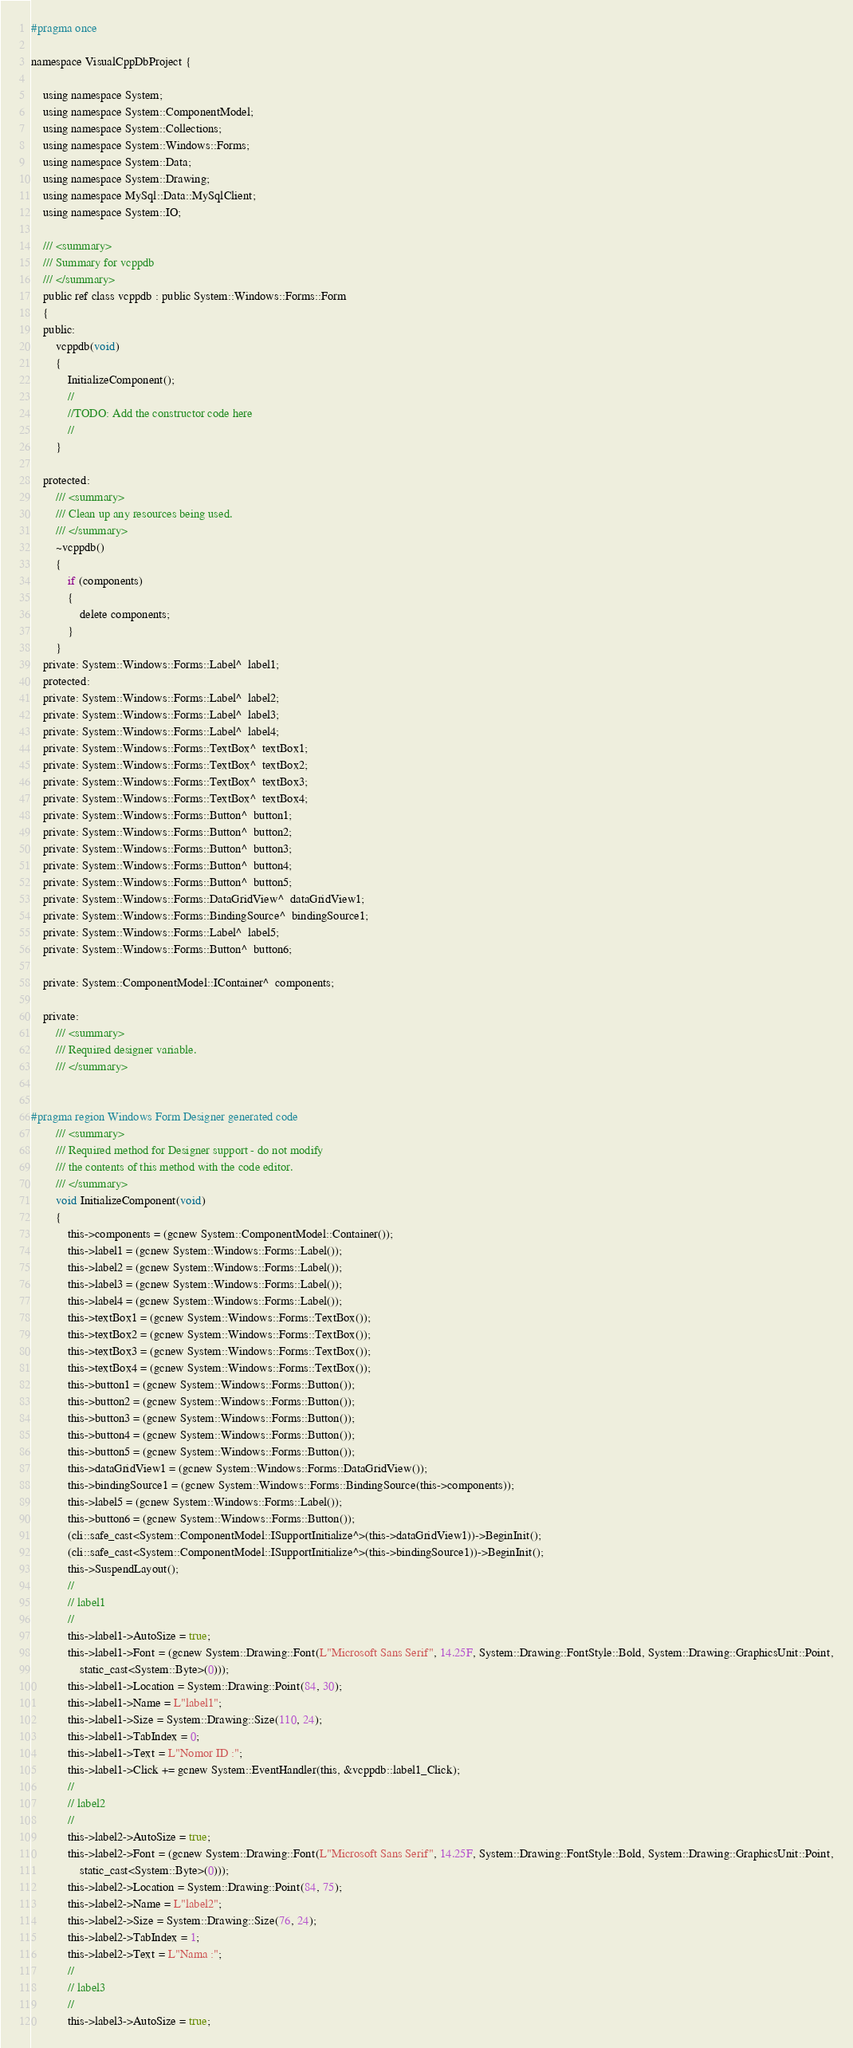<code> <loc_0><loc_0><loc_500><loc_500><_C_>#pragma once

namespace VisualCppDbProject {

	using namespace System;
	using namespace System::ComponentModel;
	using namespace System::Collections;
	using namespace System::Windows::Forms;
	using namespace System::Data;
	using namespace System::Drawing;
	using namespace MySql::Data::MySqlClient;
	using namespace System::IO;

	/// <summary>
	/// Summary for vcppdb
	/// </summary>
	public ref class vcppdb : public System::Windows::Forms::Form
	{
	public:
		vcppdb(void)
		{
			InitializeComponent();
			//
			//TODO: Add the constructor code here
			//
		}

	protected:
		/// <summary>
		/// Clean up any resources being used.
		/// </summary>
		~vcppdb()
		{
			if (components)
			{
				delete components;
			}
		}
	private: System::Windows::Forms::Label^  label1;
	protected: 
	private: System::Windows::Forms::Label^  label2;
	private: System::Windows::Forms::Label^  label3;
	private: System::Windows::Forms::Label^  label4;
	private: System::Windows::Forms::TextBox^  textBox1;
	private: System::Windows::Forms::TextBox^  textBox2;
	private: System::Windows::Forms::TextBox^  textBox3;
	private: System::Windows::Forms::TextBox^  textBox4;
	private: System::Windows::Forms::Button^  button1;
	private: System::Windows::Forms::Button^  button2;
	private: System::Windows::Forms::Button^  button3;
	private: System::Windows::Forms::Button^  button4;
	private: System::Windows::Forms::Button^  button5;
	private: System::Windows::Forms::DataGridView^  dataGridView1;
	private: System::Windows::Forms::BindingSource^  bindingSource1;
	private: System::Windows::Forms::Label^  label5;
	private: System::Windows::Forms::Button^  button6;

	private: System::ComponentModel::IContainer^  components;

	private:
		/// <summary>
		/// Required designer variable.
		/// </summary>


#pragma region Windows Form Designer generated code
		/// <summary>
		/// Required method for Designer support - do not modify
		/// the contents of this method with the code editor.
		/// </summary>
		void InitializeComponent(void)
		{
			this->components = (gcnew System::ComponentModel::Container());
			this->label1 = (gcnew System::Windows::Forms::Label());
			this->label2 = (gcnew System::Windows::Forms::Label());
			this->label3 = (gcnew System::Windows::Forms::Label());
			this->label4 = (gcnew System::Windows::Forms::Label());
			this->textBox1 = (gcnew System::Windows::Forms::TextBox());
			this->textBox2 = (gcnew System::Windows::Forms::TextBox());
			this->textBox3 = (gcnew System::Windows::Forms::TextBox());
			this->textBox4 = (gcnew System::Windows::Forms::TextBox());
			this->button1 = (gcnew System::Windows::Forms::Button());
			this->button2 = (gcnew System::Windows::Forms::Button());
			this->button3 = (gcnew System::Windows::Forms::Button());
			this->button4 = (gcnew System::Windows::Forms::Button());
			this->button5 = (gcnew System::Windows::Forms::Button());
			this->dataGridView1 = (gcnew System::Windows::Forms::DataGridView());
			this->bindingSource1 = (gcnew System::Windows::Forms::BindingSource(this->components));
			this->label5 = (gcnew System::Windows::Forms::Label());
			this->button6 = (gcnew System::Windows::Forms::Button());
			(cli::safe_cast<System::ComponentModel::ISupportInitialize^>(this->dataGridView1))->BeginInit();
			(cli::safe_cast<System::ComponentModel::ISupportInitialize^>(this->bindingSource1))->BeginInit();
			this->SuspendLayout();
			// 
			// label1
			// 
			this->label1->AutoSize = true;
			this->label1->Font = (gcnew System::Drawing::Font(L"Microsoft Sans Serif", 14.25F, System::Drawing::FontStyle::Bold, System::Drawing::GraphicsUnit::Point,
				static_cast<System::Byte>(0)));
			this->label1->Location = System::Drawing::Point(84, 30);
			this->label1->Name = L"label1";
			this->label1->Size = System::Drawing::Size(110, 24);
			this->label1->TabIndex = 0;
			this->label1->Text = L"Nomor ID :";
			this->label1->Click += gcnew System::EventHandler(this, &vcppdb::label1_Click);
			// 
			// label2
			// 
			this->label2->AutoSize = true;
			this->label2->Font = (gcnew System::Drawing::Font(L"Microsoft Sans Serif", 14.25F, System::Drawing::FontStyle::Bold, System::Drawing::GraphicsUnit::Point,
				static_cast<System::Byte>(0)));
			this->label2->Location = System::Drawing::Point(84, 75);
			this->label2->Name = L"label2";
			this->label2->Size = System::Drawing::Size(76, 24);
			this->label2->TabIndex = 1;
			this->label2->Text = L"Nama :";
			// 
			// label3
			// 
			this->label3->AutoSize = true;</code> 